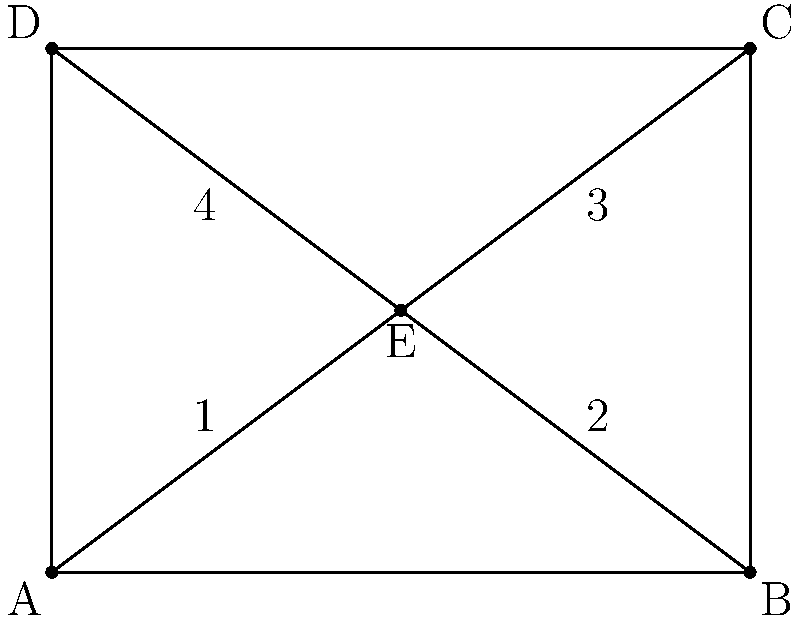Remember our favorite childhood board game with the star-shaped pieces? Let's revisit it with a geometry twist! In the diagram above, rectangle $ABCD$ represents the game board, and point $E$ is the center of the star piece. If triangles $AEB$, $BEC$, $CED$, and $DEA$ are all congruent, what is the ratio of the area of triangle $AEB$ to the area of rectangle $ABCD$? Let's approach this step-by-step:

1) First, we need to find the area of rectangle $ABCD$. 
   Area of $ABCD$ = length × width = $4 \times 3 = 12$ square units

2) Now, we need to find the area of triangle $AEB$. 
   Since all four triangles are congruent and make up the entire rectangle, 
   Area of $AEB$ = $\frac{1}{4} \times$ Area of $ABCD$ = $\frac{1}{4} \times 12 = 3$ square units

3) The ratio of the area of triangle $AEB$ to the area of rectangle $ABCD$ is:
   $\frac{\text{Area of AEB}}{\text{Area of ABCD}} = \frac{3}{12} = \frac{1}{4}$

Therefore, the ratio of the area of triangle $AEB$ to the area of rectangle $ABCD$ is $1:4$ or $\frac{1}{4}$.
Answer: $\frac{1}{4}$ 